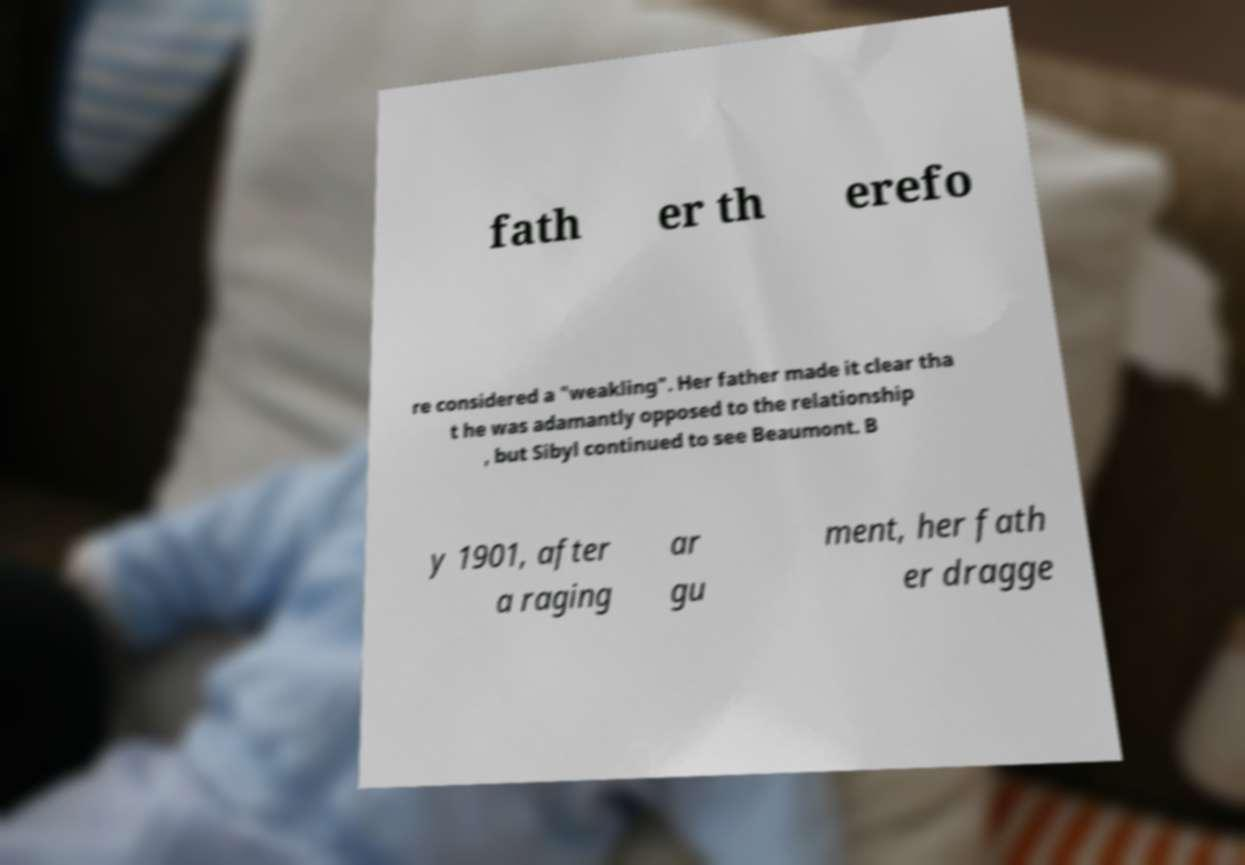For documentation purposes, I need the text within this image transcribed. Could you provide that? fath er th erefo re considered a "weakling". Her father made it clear tha t he was adamantly opposed to the relationship , but Sibyl continued to see Beaumont. B y 1901, after a raging ar gu ment, her fath er dragge 